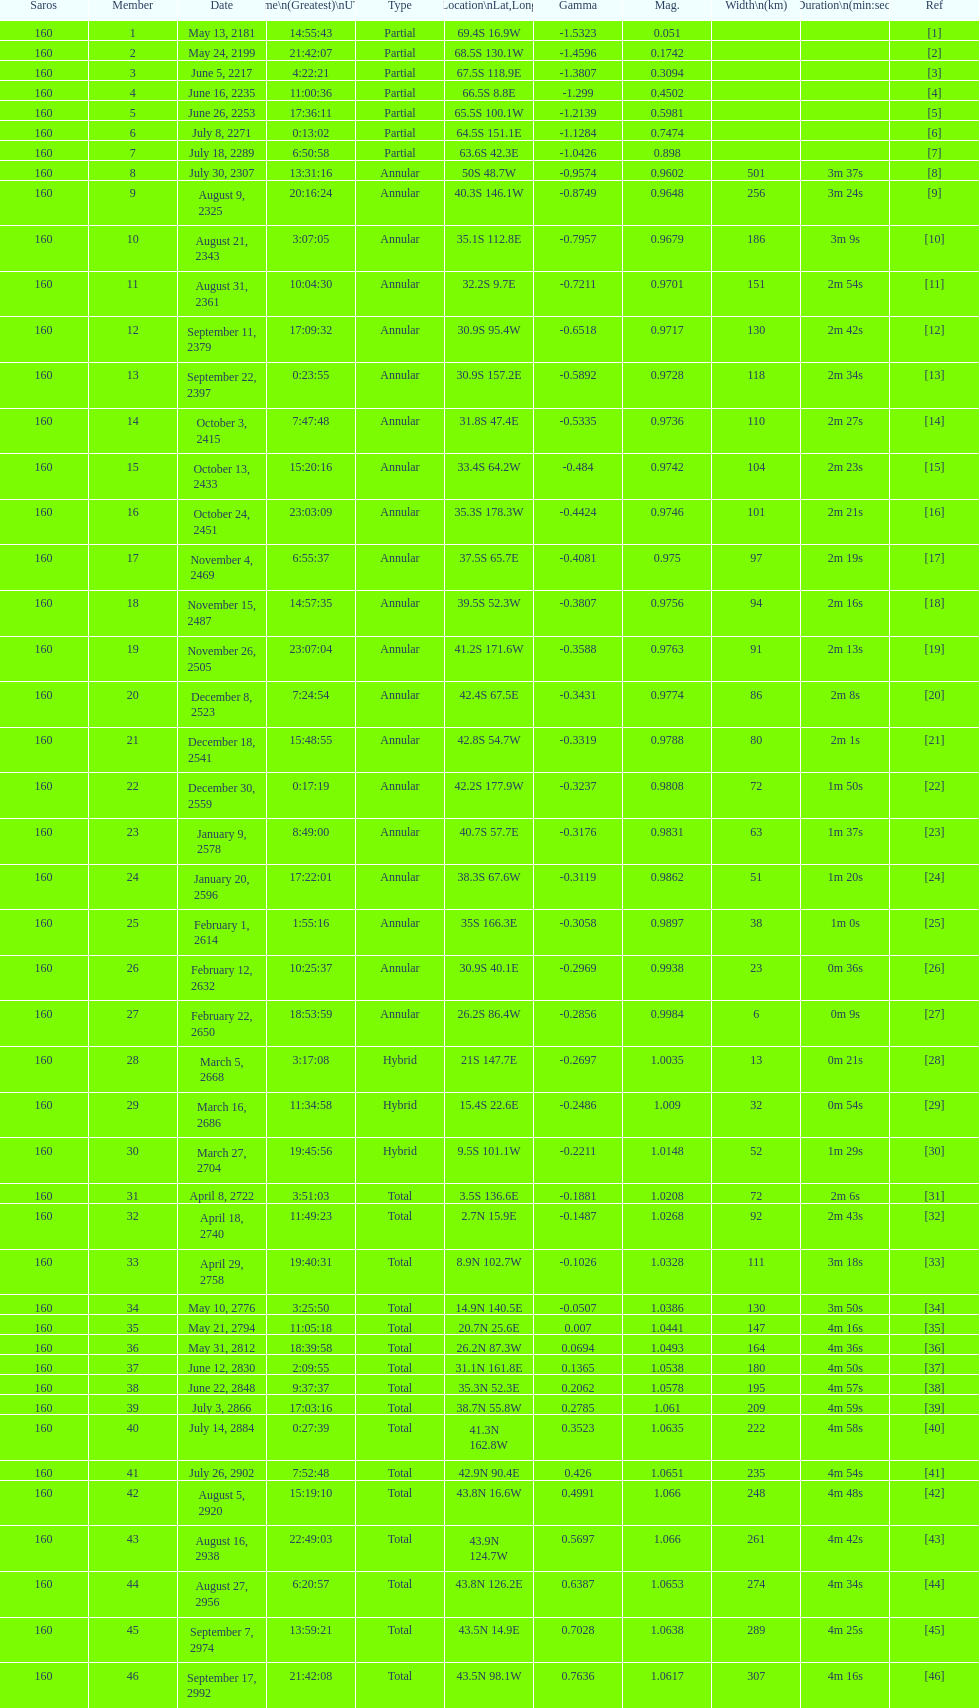When did the first solar saros with a magnitude of greater than 1.00 occur? March 5, 2668. Could you parse the entire table? {'header': ['Saros', 'Member', 'Date', 'Time\\n(Greatest)\\nUTC', 'Type', 'Location\\nLat,Long', 'Gamma', 'Mag.', 'Width\\n(km)', 'Duration\\n(min:sec)', 'Ref'], 'rows': [['160', '1', 'May 13, 2181', '14:55:43', 'Partial', '69.4S 16.9W', '-1.5323', '0.051', '', '', '[1]'], ['160', '2', 'May 24, 2199', '21:42:07', 'Partial', '68.5S 130.1W', '-1.4596', '0.1742', '', '', '[2]'], ['160', '3', 'June 5, 2217', '4:22:21', 'Partial', '67.5S 118.9E', '-1.3807', '0.3094', '', '', '[3]'], ['160', '4', 'June 16, 2235', '11:00:36', 'Partial', '66.5S 8.8E', '-1.299', '0.4502', '', '', '[4]'], ['160', '5', 'June 26, 2253', '17:36:11', 'Partial', '65.5S 100.1W', '-1.2139', '0.5981', '', '', '[5]'], ['160', '6', 'July 8, 2271', '0:13:02', 'Partial', '64.5S 151.1E', '-1.1284', '0.7474', '', '', '[6]'], ['160', '7', 'July 18, 2289', '6:50:58', 'Partial', '63.6S 42.3E', '-1.0426', '0.898', '', '', '[7]'], ['160', '8', 'July 30, 2307', '13:31:16', 'Annular', '50S 48.7W', '-0.9574', '0.9602', '501', '3m 37s', '[8]'], ['160', '9', 'August 9, 2325', '20:16:24', 'Annular', '40.3S 146.1W', '-0.8749', '0.9648', '256', '3m 24s', '[9]'], ['160', '10', 'August 21, 2343', '3:07:05', 'Annular', '35.1S 112.8E', '-0.7957', '0.9679', '186', '3m 9s', '[10]'], ['160', '11', 'August 31, 2361', '10:04:30', 'Annular', '32.2S 9.7E', '-0.7211', '0.9701', '151', '2m 54s', '[11]'], ['160', '12', 'September 11, 2379', '17:09:32', 'Annular', '30.9S 95.4W', '-0.6518', '0.9717', '130', '2m 42s', '[12]'], ['160', '13', 'September 22, 2397', '0:23:55', 'Annular', '30.9S 157.2E', '-0.5892', '0.9728', '118', '2m 34s', '[13]'], ['160', '14', 'October 3, 2415', '7:47:48', 'Annular', '31.8S 47.4E', '-0.5335', '0.9736', '110', '2m 27s', '[14]'], ['160', '15', 'October 13, 2433', '15:20:16', 'Annular', '33.4S 64.2W', '-0.484', '0.9742', '104', '2m 23s', '[15]'], ['160', '16', 'October 24, 2451', '23:03:09', 'Annular', '35.3S 178.3W', '-0.4424', '0.9746', '101', '2m 21s', '[16]'], ['160', '17', 'November 4, 2469', '6:55:37', 'Annular', '37.5S 65.7E', '-0.4081', '0.975', '97', '2m 19s', '[17]'], ['160', '18', 'November 15, 2487', '14:57:35', 'Annular', '39.5S 52.3W', '-0.3807', '0.9756', '94', '2m 16s', '[18]'], ['160', '19', 'November 26, 2505', '23:07:04', 'Annular', '41.2S 171.6W', '-0.3588', '0.9763', '91', '2m 13s', '[19]'], ['160', '20', 'December 8, 2523', '7:24:54', 'Annular', '42.4S 67.5E', '-0.3431', '0.9774', '86', '2m 8s', '[20]'], ['160', '21', 'December 18, 2541', '15:48:55', 'Annular', '42.8S 54.7W', '-0.3319', '0.9788', '80', '2m 1s', '[21]'], ['160', '22', 'December 30, 2559', '0:17:19', 'Annular', '42.2S 177.9W', '-0.3237', '0.9808', '72', '1m 50s', '[22]'], ['160', '23', 'January 9, 2578', '8:49:00', 'Annular', '40.7S 57.7E', '-0.3176', '0.9831', '63', '1m 37s', '[23]'], ['160', '24', 'January 20, 2596', '17:22:01', 'Annular', '38.3S 67.6W', '-0.3119', '0.9862', '51', '1m 20s', '[24]'], ['160', '25', 'February 1, 2614', '1:55:16', 'Annular', '35S 166.3E', '-0.3058', '0.9897', '38', '1m 0s', '[25]'], ['160', '26', 'February 12, 2632', '10:25:37', 'Annular', '30.9S 40.1E', '-0.2969', '0.9938', '23', '0m 36s', '[26]'], ['160', '27', 'February 22, 2650', '18:53:59', 'Annular', '26.2S 86.4W', '-0.2856', '0.9984', '6', '0m 9s', '[27]'], ['160', '28', 'March 5, 2668', '3:17:08', 'Hybrid', '21S 147.7E', '-0.2697', '1.0035', '13', '0m 21s', '[28]'], ['160', '29', 'March 16, 2686', '11:34:58', 'Hybrid', '15.4S 22.6E', '-0.2486', '1.009', '32', '0m 54s', '[29]'], ['160', '30', 'March 27, 2704', '19:45:56', 'Hybrid', '9.5S 101.1W', '-0.2211', '1.0148', '52', '1m 29s', '[30]'], ['160', '31', 'April 8, 2722', '3:51:03', 'Total', '3.5S 136.6E', '-0.1881', '1.0208', '72', '2m 6s', '[31]'], ['160', '32', 'April 18, 2740', '11:49:23', 'Total', '2.7N 15.9E', '-0.1487', '1.0268', '92', '2m 43s', '[32]'], ['160', '33', 'April 29, 2758', '19:40:31', 'Total', '8.9N 102.7W', '-0.1026', '1.0328', '111', '3m 18s', '[33]'], ['160', '34', 'May 10, 2776', '3:25:50', 'Total', '14.9N 140.5E', '-0.0507', '1.0386', '130', '3m 50s', '[34]'], ['160', '35', 'May 21, 2794', '11:05:18', 'Total', '20.7N 25.6E', '0.007', '1.0441', '147', '4m 16s', '[35]'], ['160', '36', 'May 31, 2812', '18:39:58', 'Total', '26.2N 87.3W', '0.0694', '1.0493', '164', '4m 36s', '[36]'], ['160', '37', 'June 12, 2830', '2:09:55', 'Total', '31.1N 161.8E', '0.1365', '1.0538', '180', '4m 50s', '[37]'], ['160', '38', 'June 22, 2848', '9:37:37', 'Total', '35.3N 52.3E', '0.2062', '1.0578', '195', '4m 57s', '[38]'], ['160', '39', 'July 3, 2866', '17:03:16', 'Total', '38.7N 55.8W', '0.2785', '1.061', '209', '4m 59s', '[39]'], ['160', '40', 'July 14, 2884', '0:27:39', 'Total', '41.3N 162.8W', '0.3523', '1.0635', '222', '4m 58s', '[40]'], ['160', '41', 'July 26, 2902', '7:52:48', 'Total', '42.9N 90.4E', '0.426', '1.0651', '235', '4m 54s', '[41]'], ['160', '42', 'August 5, 2920', '15:19:10', 'Total', '43.8N 16.6W', '0.4991', '1.066', '248', '4m 48s', '[42]'], ['160', '43', 'August 16, 2938', '22:49:03', 'Total', '43.9N 124.7W', '0.5697', '1.066', '261', '4m 42s', '[43]'], ['160', '44', 'August 27, 2956', '6:20:57', 'Total', '43.8N 126.2E', '0.6387', '1.0653', '274', '4m 34s', '[44]'], ['160', '45', 'September 7, 2974', '13:59:21', 'Total', '43.5N 14.9E', '0.7028', '1.0638', '289', '4m 25s', '[45]'], ['160', '46', 'September 17, 2992', '21:42:08', 'Total', '43.5N 98.1W', '0.7636', '1.0617', '307', '4m 16s', '[46]']]} 